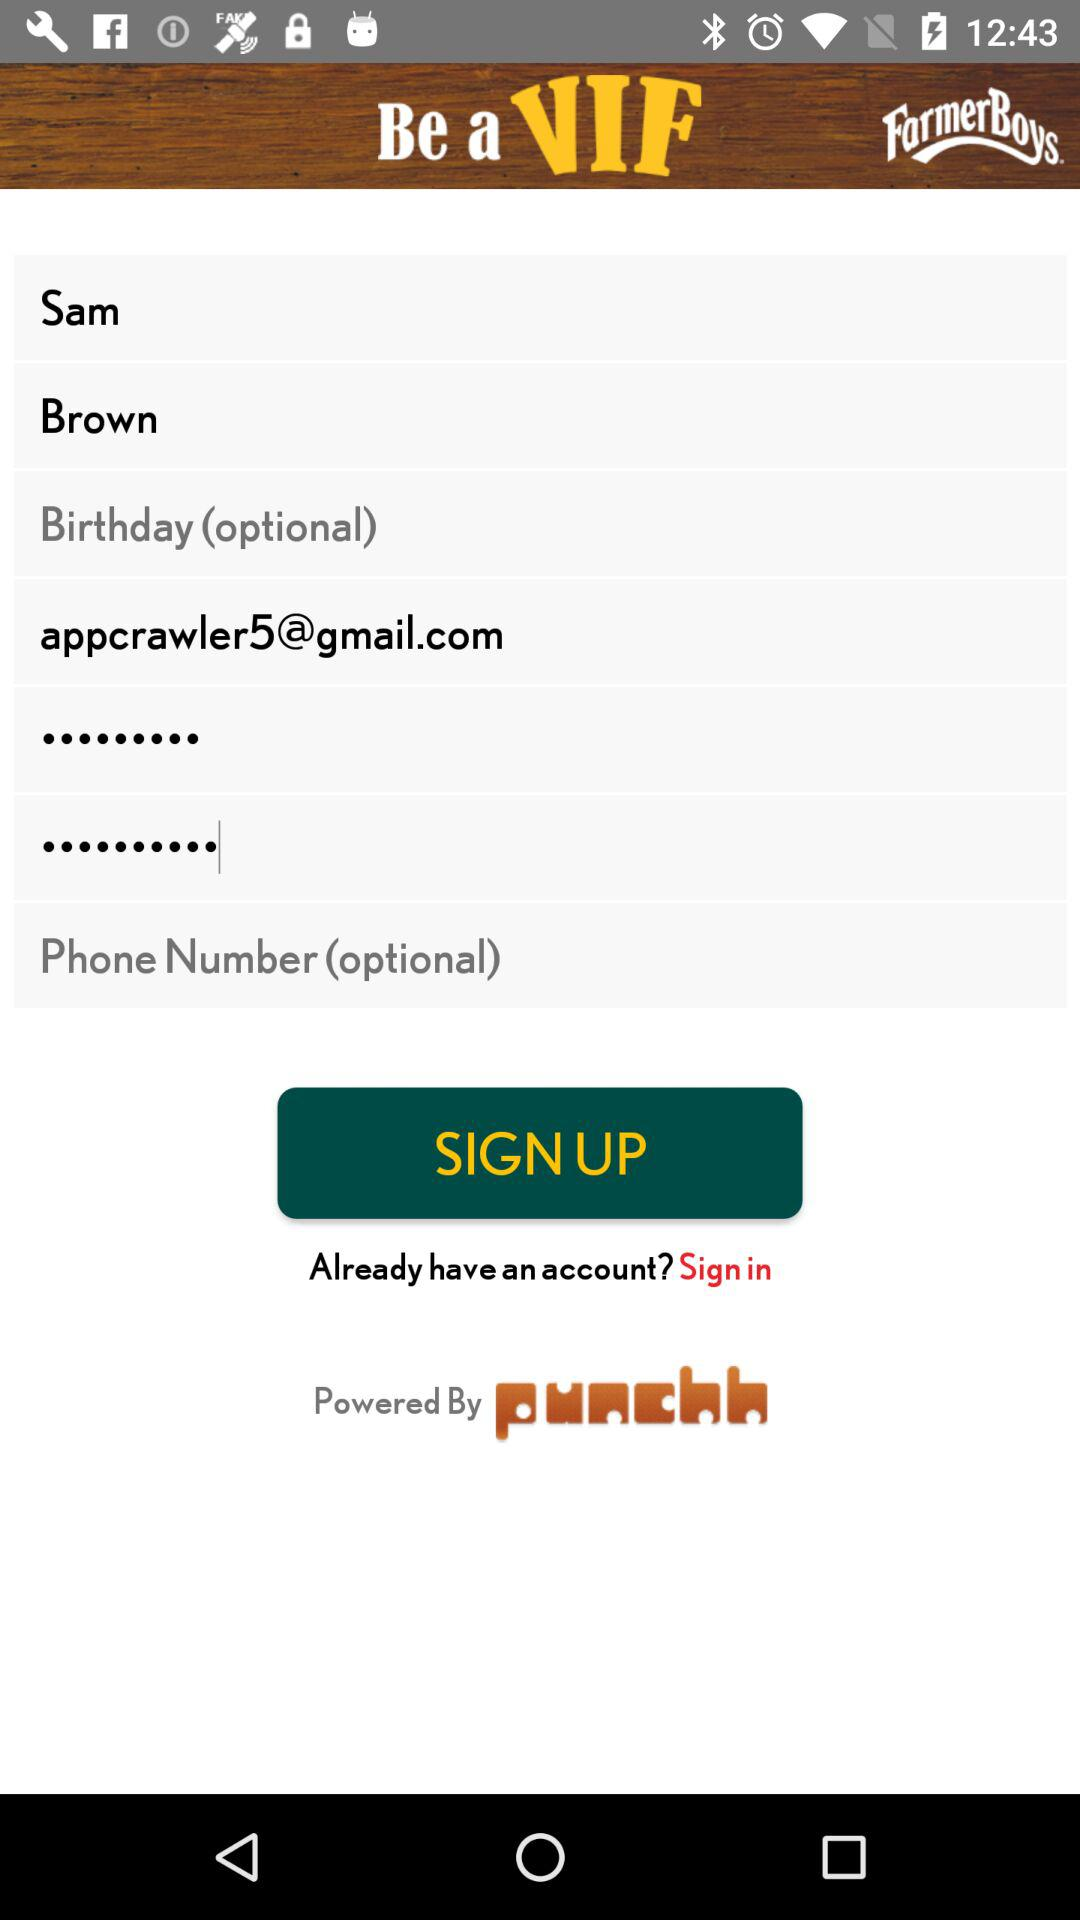What is the name of the user? The name of the user is Sam Brown. 